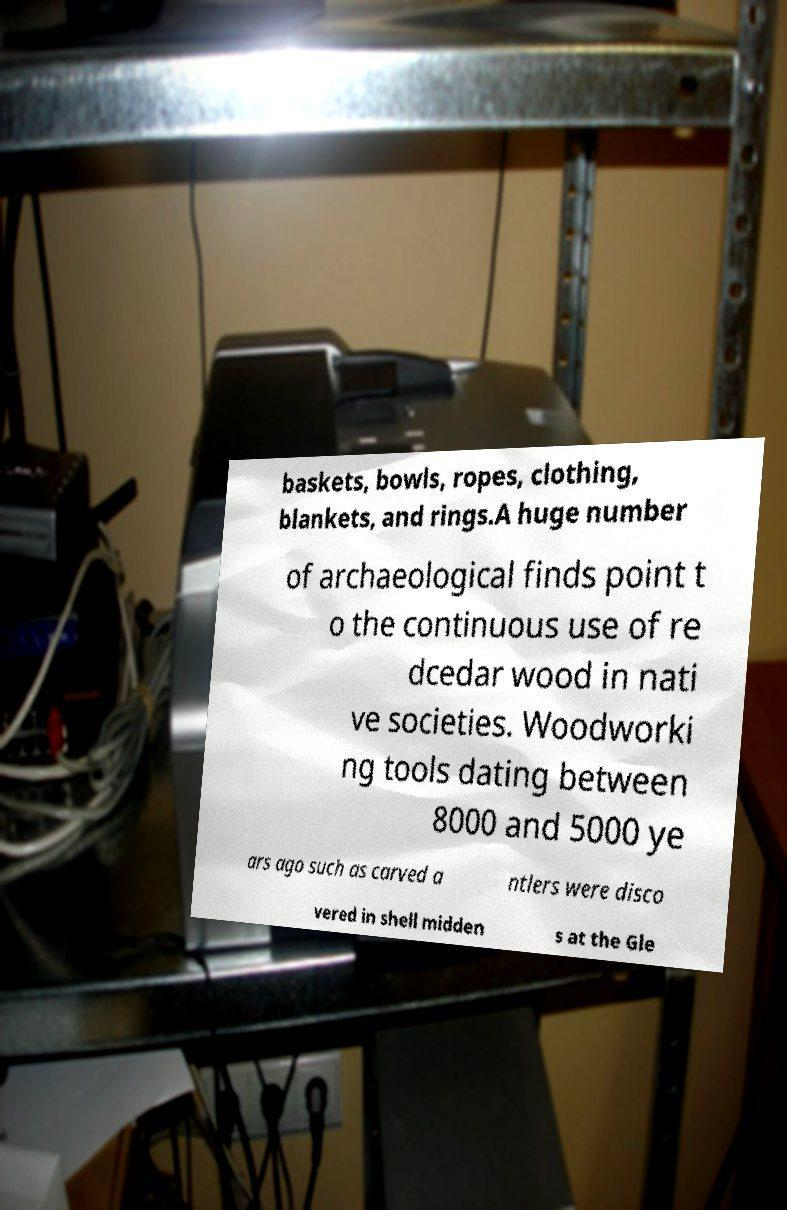For documentation purposes, I need the text within this image transcribed. Could you provide that? baskets, bowls, ropes, clothing, blankets, and rings.A huge number of archaeological finds point t o the continuous use of re dcedar wood in nati ve societies. Woodworki ng tools dating between 8000 and 5000 ye ars ago such as carved a ntlers were disco vered in shell midden s at the Gle 